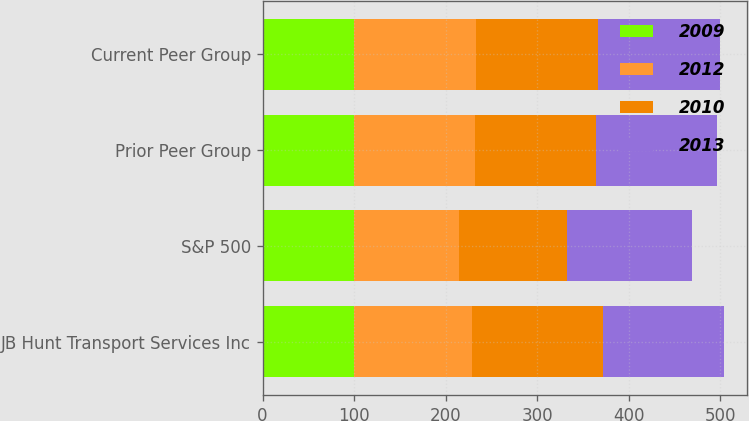Convert chart to OTSL. <chart><loc_0><loc_0><loc_500><loc_500><stacked_bar_chart><ecel><fcel>JB Hunt Transport Services Inc<fcel>S&P 500<fcel>Prior Peer Group<fcel>Current Peer Group<nl><fcel>2009<fcel>100<fcel>100<fcel>100<fcel>100<nl><fcel>2012<fcel>128.22<fcel>115.06<fcel>132.52<fcel>133.45<nl><fcel>2010<fcel>143.28<fcel>117.49<fcel>131.99<fcel>132.52<nl><fcel>2013<fcel>131.99<fcel>136.3<fcel>132.26<fcel>134.09<nl></chart> 